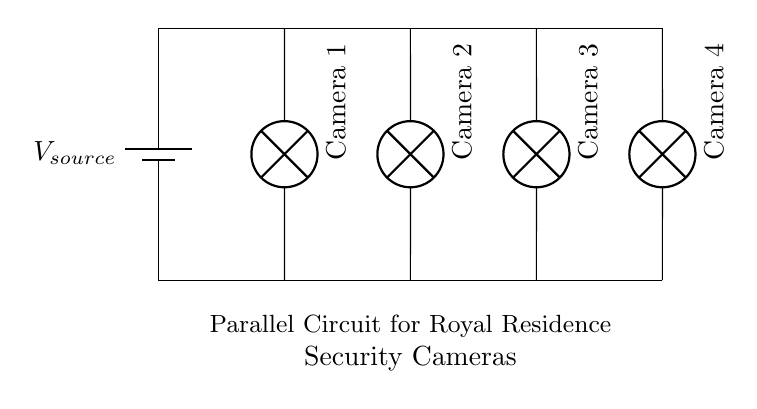What is the total number of security cameras connected? The circuit diagram shows four individual cameras connected in parallel to the power source, indicated by the four lamp symbols labeled "Camera 1" through "Camera 4."
Answer: four What type of circuit is used in this diagram? The main feature of the circuit is that multiple components (in this case, cameras) are connected across the same voltage source, demonstrating a parallel circuit where each camera operates independently from the others.
Answer: parallel What is the role of the battery in this circuit? The battery serves as the voltage source for the circuit, providing the necessary electric power for all connected security cameras to function simultaneously.
Answer: voltage source Which component receives the same voltage supply? In a parallel circuit, all components are connected directly to the same voltage source, thus each camera receives the same voltage provided by the battery.
Answer: each camera If one camera fails, what happens to the others? Since this is a parallel circuit, the functionality of one camera does not affect the others; if one fails, the remaining cameras will continue to operate as they are independently connected to the voltage source.
Answer: continue to operate What voltage is supplied to each camera? All cameras are connected in parallel to the same voltage source, meaning that each camera receives the same voltage as provided by the battery, which is a characteristic of parallel circuits.
Answer: the same as the battery voltage 